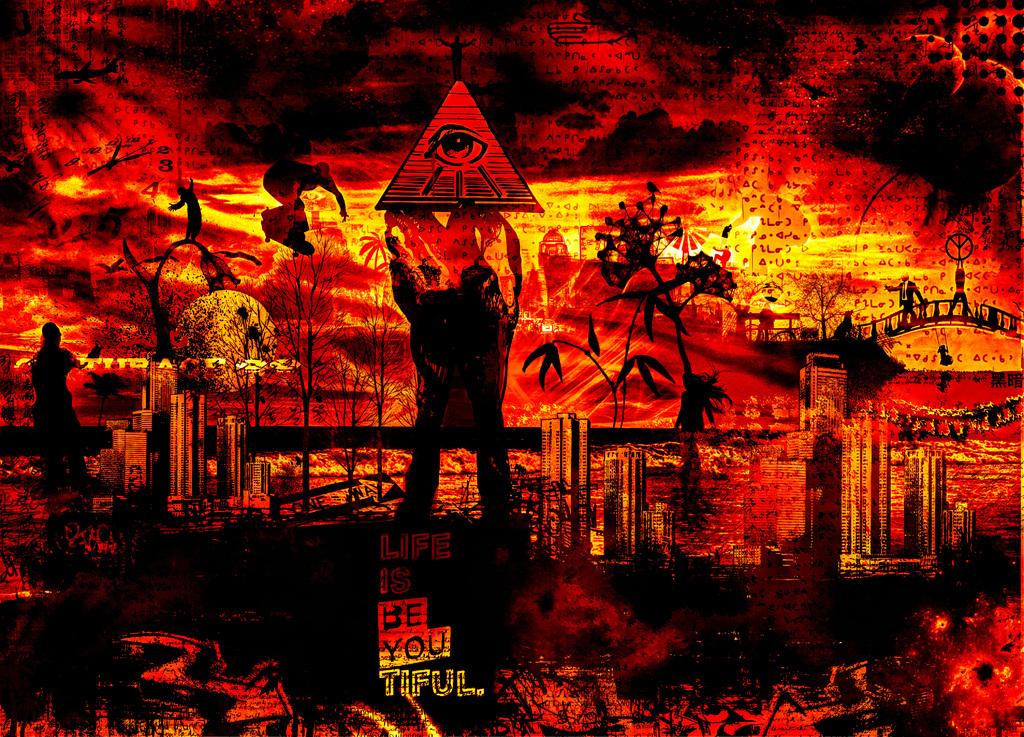What is life?
Give a very brief answer. Be you tiful. What´s the part of the body on the triangle?
Offer a very short reply. Eye. 